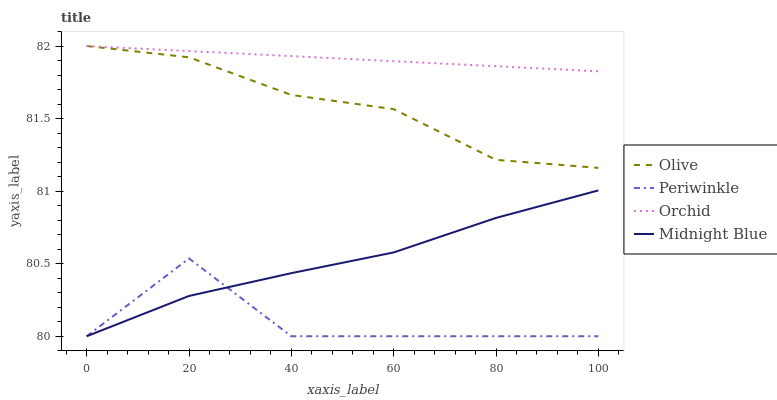Does Periwinkle have the minimum area under the curve?
Answer yes or no. Yes. Does Orchid have the maximum area under the curve?
Answer yes or no. Yes. Does Midnight Blue have the minimum area under the curve?
Answer yes or no. No. Does Midnight Blue have the maximum area under the curve?
Answer yes or no. No. Is Orchid the smoothest?
Answer yes or no. Yes. Is Periwinkle the roughest?
Answer yes or no. Yes. Is Midnight Blue the smoothest?
Answer yes or no. No. Is Midnight Blue the roughest?
Answer yes or no. No. Does Periwinkle have the lowest value?
Answer yes or no. Yes. Does Orchid have the lowest value?
Answer yes or no. No. Does Orchid have the highest value?
Answer yes or no. Yes. Does Midnight Blue have the highest value?
Answer yes or no. No. Is Periwinkle less than Orchid?
Answer yes or no. Yes. Is Orchid greater than Midnight Blue?
Answer yes or no. Yes. Does Olive intersect Orchid?
Answer yes or no. Yes. Is Olive less than Orchid?
Answer yes or no. No. Is Olive greater than Orchid?
Answer yes or no. No. Does Periwinkle intersect Orchid?
Answer yes or no. No. 